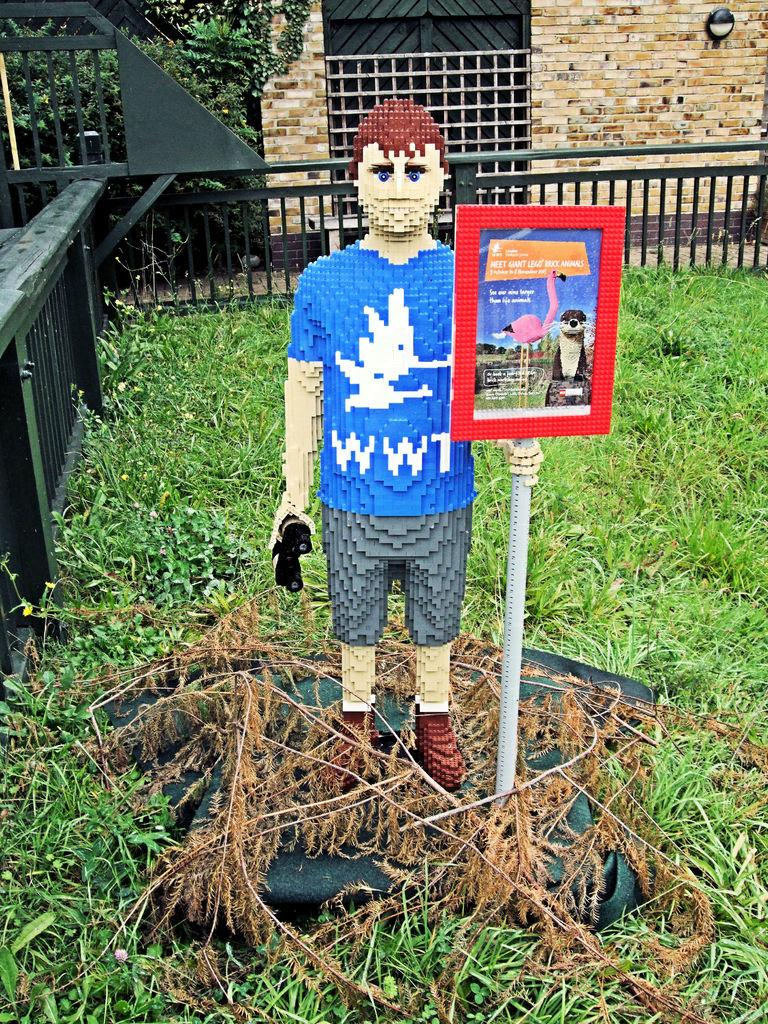What is the main subject in the center of the image? There is a statue in the center of the image. What type of vegetation is at the bottom of the image? There is grass at the bottom of the image. What structures can be seen in the background of the image? There is a fence, a wall, and a gate in the background of the image. What type of story is the doctor telling at the gate in the image? There is no doctor or story present in the image; it features a statue, grass, and structures in the background. 